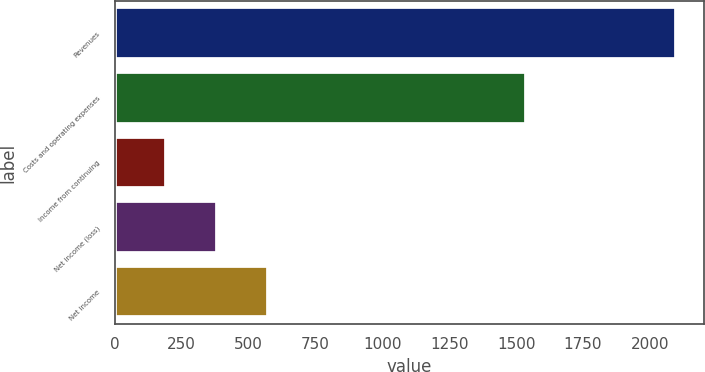<chart> <loc_0><loc_0><loc_500><loc_500><bar_chart><fcel>Revenues<fcel>Costs and operating expenses<fcel>Income from continuing<fcel>Net income (loss)<fcel>Net income<nl><fcel>2098<fcel>1537<fcel>192<fcel>382.6<fcel>573.2<nl></chart> 